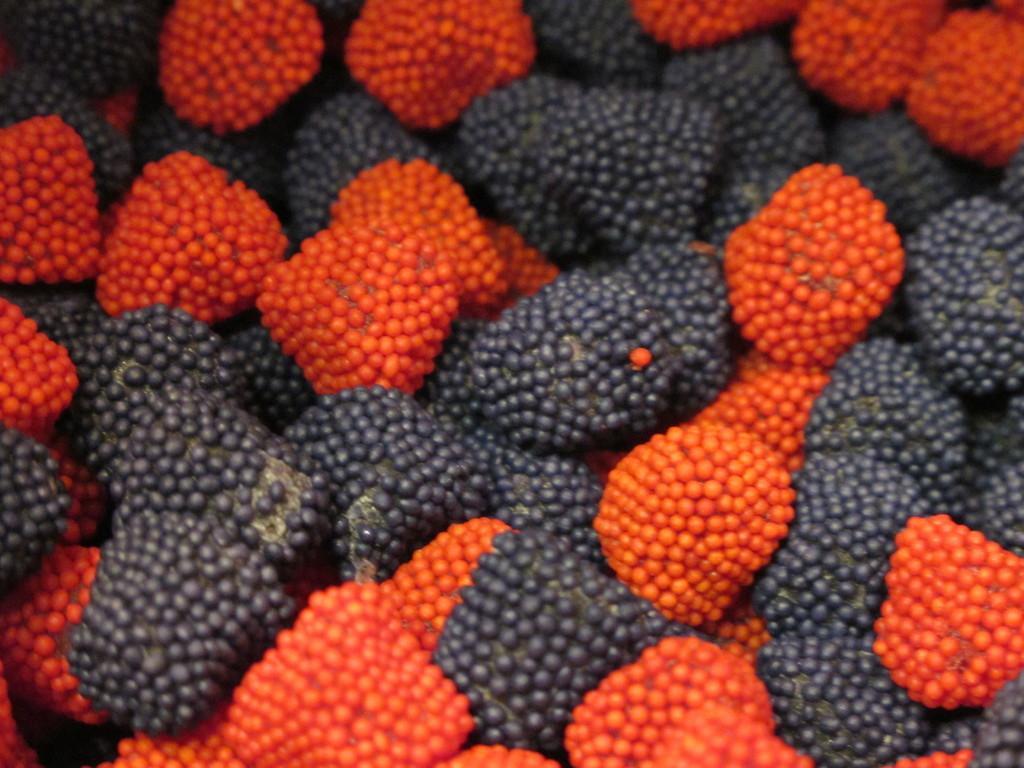How would you summarize this image in a sentence or two? In this image we can see berries which are in black and red color. 